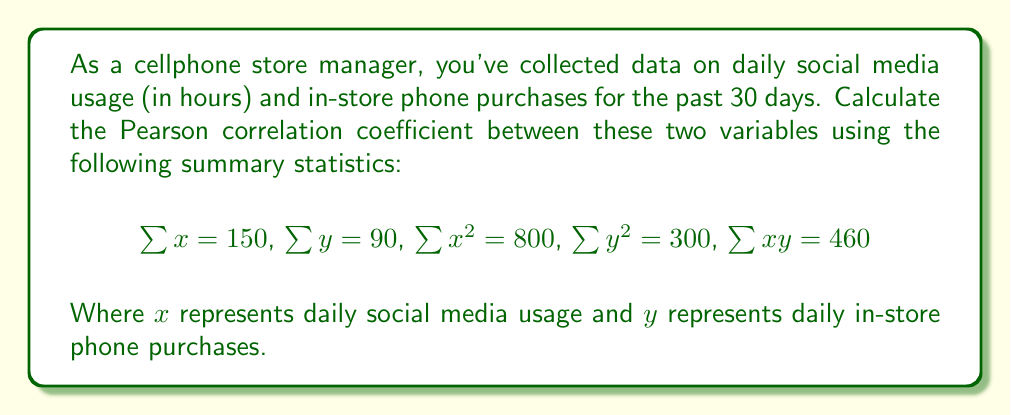Help me with this question. To calculate the Pearson correlation coefficient, we'll use the formula:

$$r = \frac{n\sum xy - \sum x \sum y}{\sqrt{[n\sum x^2 - (\sum x)^2][n\sum y^2 - (\sum y)^2]}}$$

Where $n$ is the number of data points (30 in this case).

Let's substitute the given values:

1. $n = 30$
2. $\sum x = 150$
3. $\sum y = 90$
4. $\sum x^2 = 800$
5. $\sum y^2 = 300$
6. $\sum xy = 460$

Now, let's calculate step by step:

1. Numerator: $30(460) - (150)(90) = 13800 - 13500 = 300$

2. Denominator:
   a. $[30(800) - (150)^2] = 24000 - 22500 = 1500$
   b. $[30(300) - (90)^2] = 9000 - 8100 = 900$
   c. $\sqrt{1500 \times 900} = \sqrt{1350000} \approx 1162.0$

3. Putting it all together:

   $$r = \frac{300}{1162.0} \approx 0.2582$$
Answer: The Pearson correlation coefficient between daily social media usage and in-store phone purchases is approximately 0.2582. 